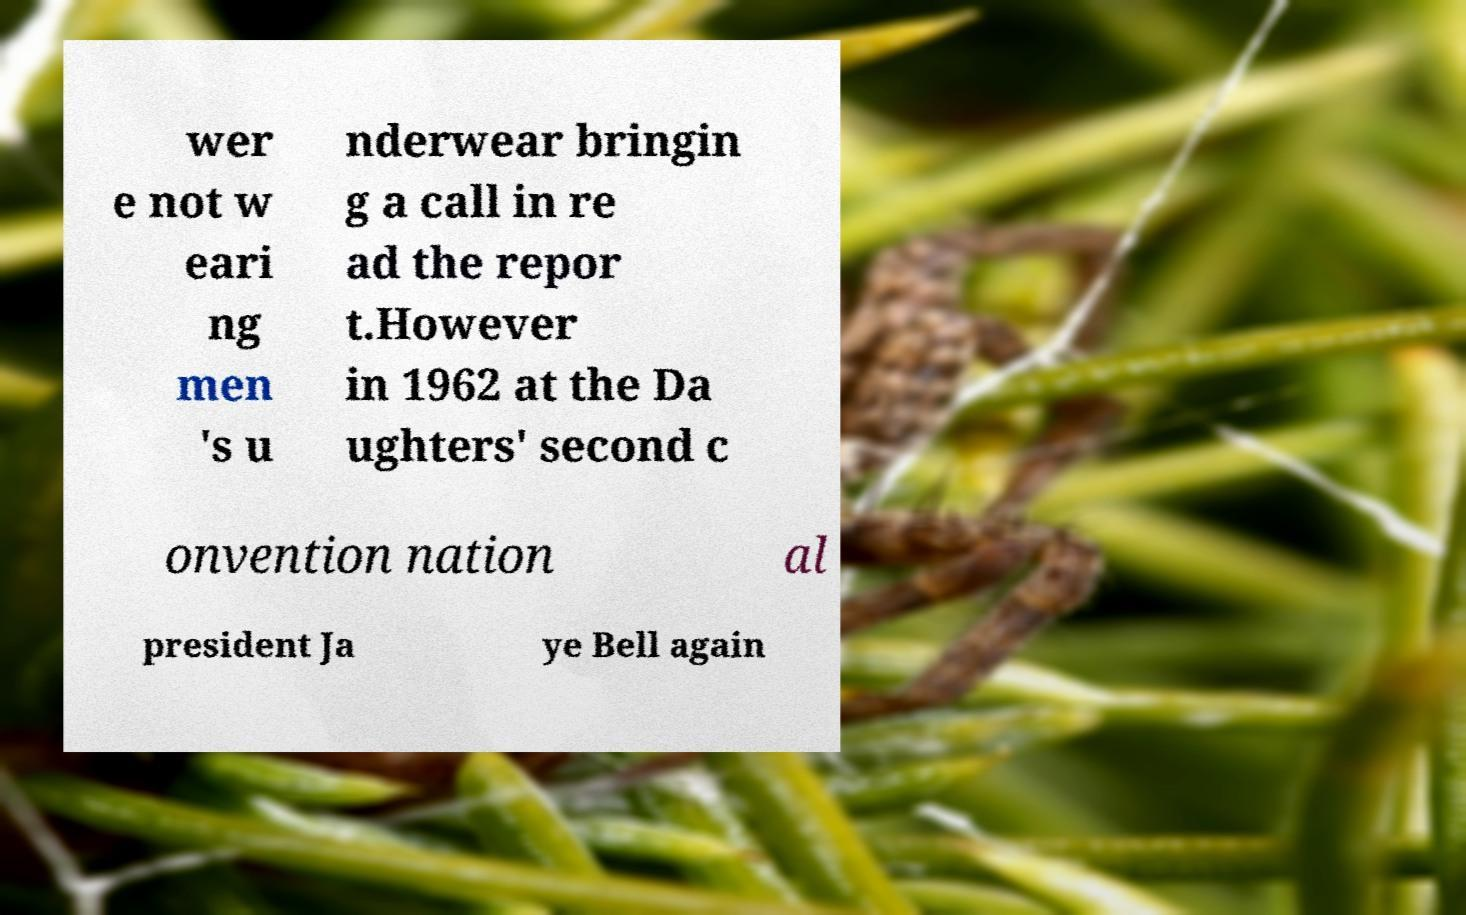I need the written content from this picture converted into text. Can you do that? wer e not w eari ng men 's u nderwear bringin g a call in re ad the repor t.However in 1962 at the Da ughters' second c onvention nation al president Ja ye Bell again 